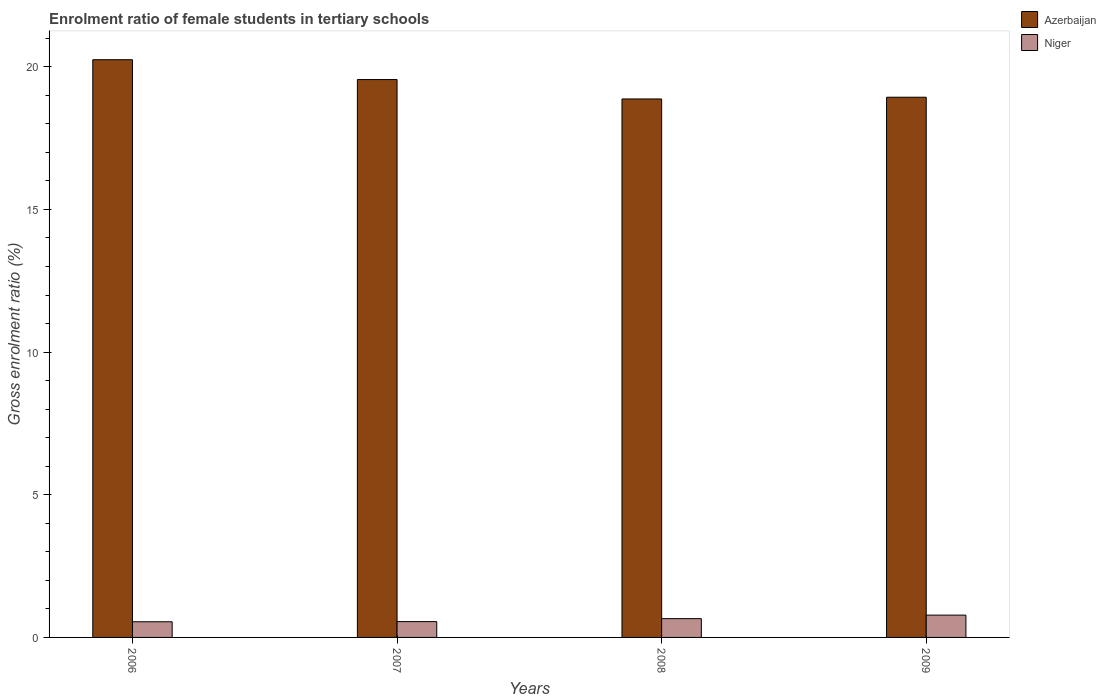What is the enrolment ratio of female students in tertiary schools in Niger in 2009?
Ensure brevity in your answer.  0.78. Across all years, what is the maximum enrolment ratio of female students in tertiary schools in Niger?
Provide a succinct answer. 0.78. Across all years, what is the minimum enrolment ratio of female students in tertiary schools in Niger?
Provide a short and direct response. 0.55. What is the total enrolment ratio of female students in tertiary schools in Azerbaijan in the graph?
Provide a short and direct response. 77.6. What is the difference between the enrolment ratio of female students in tertiary schools in Niger in 2006 and that in 2009?
Your response must be concise. -0.23. What is the difference between the enrolment ratio of female students in tertiary schools in Azerbaijan in 2008 and the enrolment ratio of female students in tertiary schools in Niger in 2006?
Your answer should be very brief. 18.32. What is the average enrolment ratio of female students in tertiary schools in Azerbaijan per year?
Give a very brief answer. 19.4. In the year 2008, what is the difference between the enrolment ratio of female students in tertiary schools in Niger and enrolment ratio of female students in tertiary schools in Azerbaijan?
Provide a succinct answer. -18.21. What is the ratio of the enrolment ratio of female students in tertiary schools in Niger in 2006 to that in 2008?
Provide a short and direct response. 0.83. Is the enrolment ratio of female students in tertiary schools in Niger in 2006 less than that in 2007?
Offer a very short reply. Yes. Is the difference between the enrolment ratio of female students in tertiary schools in Niger in 2008 and 2009 greater than the difference between the enrolment ratio of female students in tertiary schools in Azerbaijan in 2008 and 2009?
Keep it short and to the point. No. What is the difference between the highest and the second highest enrolment ratio of female students in tertiary schools in Niger?
Offer a terse response. 0.12. What is the difference between the highest and the lowest enrolment ratio of female students in tertiary schools in Azerbaijan?
Your answer should be very brief. 1.38. In how many years, is the enrolment ratio of female students in tertiary schools in Niger greater than the average enrolment ratio of female students in tertiary schools in Niger taken over all years?
Offer a terse response. 2. Is the sum of the enrolment ratio of female students in tertiary schools in Azerbaijan in 2007 and 2008 greater than the maximum enrolment ratio of female students in tertiary schools in Niger across all years?
Provide a succinct answer. Yes. What does the 2nd bar from the left in 2007 represents?
Provide a short and direct response. Niger. What does the 1st bar from the right in 2006 represents?
Your answer should be very brief. Niger. What is the difference between two consecutive major ticks on the Y-axis?
Your response must be concise. 5. Are the values on the major ticks of Y-axis written in scientific E-notation?
Ensure brevity in your answer.  No. Does the graph contain any zero values?
Give a very brief answer. No. How many legend labels are there?
Ensure brevity in your answer.  2. What is the title of the graph?
Make the answer very short. Enrolment ratio of female students in tertiary schools. Does "Least developed countries" appear as one of the legend labels in the graph?
Ensure brevity in your answer.  No. What is the label or title of the X-axis?
Keep it short and to the point. Years. What is the label or title of the Y-axis?
Your answer should be compact. Gross enrolment ratio (%). What is the Gross enrolment ratio (%) of Azerbaijan in 2006?
Provide a succinct answer. 20.25. What is the Gross enrolment ratio (%) of Niger in 2006?
Offer a terse response. 0.55. What is the Gross enrolment ratio (%) in Azerbaijan in 2007?
Provide a short and direct response. 19.55. What is the Gross enrolment ratio (%) in Niger in 2007?
Offer a terse response. 0.55. What is the Gross enrolment ratio (%) in Azerbaijan in 2008?
Provide a short and direct response. 18.87. What is the Gross enrolment ratio (%) in Niger in 2008?
Keep it short and to the point. 0.66. What is the Gross enrolment ratio (%) in Azerbaijan in 2009?
Your response must be concise. 18.93. What is the Gross enrolment ratio (%) of Niger in 2009?
Offer a terse response. 0.78. Across all years, what is the maximum Gross enrolment ratio (%) in Azerbaijan?
Make the answer very short. 20.25. Across all years, what is the maximum Gross enrolment ratio (%) of Niger?
Keep it short and to the point. 0.78. Across all years, what is the minimum Gross enrolment ratio (%) in Azerbaijan?
Keep it short and to the point. 18.87. Across all years, what is the minimum Gross enrolment ratio (%) in Niger?
Ensure brevity in your answer.  0.55. What is the total Gross enrolment ratio (%) in Azerbaijan in the graph?
Ensure brevity in your answer.  77.6. What is the total Gross enrolment ratio (%) of Niger in the graph?
Offer a very short reply. 2.54. What is the difference between the Gross enrolment ratio (%) in Azerbaijan in 2006 and that in 2007?
Your answer should be compact. 0.7. What is the difference between the Gross enrolment ratio (%) of Niger in 2006 and that in 2007?
Offer a terse response. -0.01. What is the difference between the Gross enrolment ratio (%) in Azerbaijan in 2006 and that in 2008?
Make the answer very short. 1.38. What is the difference between the Gross enrolment ratio (%) in Niger in 2006 and that in 2008?
Provide a short and direct response. -0.11. What is the difference between the Gross enrolment ratio (%) of Azerbaijan in 2006 and that in 2009?
Keep it short and to the point. 1.31. What is the difference between the Gross enrolment ratio (%) in Niger in 2006 and that in 2009?
Keep it short and to the point. -0.23. What is the difference between the Gross enrolment ratio (%) in Azerbaijan in 2007 and that in 2008?
Give a very brief answer. 0.68. What is the difference between the Gross enrolment ratio (%) in Niger in 2007 and that in 2008?
Offer a terse response. -0.1. What is the difference between the Gross enrolment ratio (%) in Azerbaijan in 2007 and that in 2009?
Offer a terse response. 0.62. What is the difference between the Gross enrolment ratio (%) in Niger in 2007 and that in 2009?
Keep it short and to the point. -0.23. What is the difference between the Gross enrolment ratio (%) of Azerbaijan in 2008 and that in 2009?
Provide a succinct answer. -0.06. What is the difference between the Gross enrolment ratio (%) in Niger in 2008 and that in 2009?
Make the answer very short. -0.12. What is the difference between the Gross enrolment ratio (%) of Azerbaijan in 2006 and the Gross enrolment ratio (%) of Niger in 2007?
Give a very brief answer. 19.69. What is the difference between the Gross enrolment ratio (%) in Azerbaijan in 2006 and the Gross enrolment ratio (%) in Niger in 2008?
Offer a terse response. 19.59. What is the difference between the Gross enrolment ratio (%) in Azerbaijan in 2006 and the Gross enrolment ratio (%) in Niger in 2009?
Give a very brief answer. 19.46. What is the difference between the Gross enrolment ratio (%) of Azerbaijan in 2007 and the Gross enrolment ratio (%) of Niger in 2008?
Provide a succinct answer. 18.89. What is the difference between the Gross enrolment ratio (%) of Azerbaijan in 2007 and the Gross enrolment ratio (%) of Niger in 2009?
Your response must be concise. 18.77. What is the difference between the Gross enrolment ratio (%) of Azerbaijan in 2008 and the Gross enrolment ratio (%) of Niger in 2009?
Offer a terse response. 18.09. What is the average Gross enrolment ratio (%) of Azerbaijan per year?
Offer a very short reply. 19.4. What is the average Gross enrolment ratio (%) of Niger per year?
Provide a succinct answer. 0.64. In the year 2006, what is the difference between the Gross enrolment ratio (%) in Azerbaijan and Gross enrolment ratio (%) in Niger?
Offer a terse response. 19.7. In the year 2007, what is the difference between the Gross enrolment ratio (%) of Azerbaijan and Gross enrolment ratio (%) of Niger?
Your response must be concise. 19. In the year 2008, what is the difference between the Gross enrolment ratio (%) in Azerbaijan and Gross enrolment ratio (%) in Niger?
Give a very brief answer. 18.21. In the year 2009, what is the difference between the Gross enrolment ratio (%) in Azerbaijan and Gross enrolment ratio (%) in Niger?
Provide a short and direct response. 18.15. What is the ratio of the Gross enrolment ratio (%) in Azerbaijan in 2006 to that in 2007?
Ensure brevity in your answer.  1.04. What is the ratio of the Gross enrolment ratio (%) of Azerbaijan in 2006 to that in 2008?
Your response must be concise. 1.07. What is the ratio of the Gross enrolment ratio (%) of Niger in 2006 to that in 2008?
Your answer should be very brief. 0.83. What is the ratio of the Gross enrolment ratio (%) in Azerbaijan in 2006 to that in 2009?
Your response must be concise. 1.07. What is the ratio of the Gross enrolment ratio (%) in Niger in 2006 to that in 2009?
Your answer should be compact. 0.7. What is the ratio of the Gross enrolment ratio (%) of Azerbaijan in 2007 to that in 2008?
Make the answer very short. 1.04. What is the ratio of the Gross enrolment ratio (%) of Niger in 2007 to that in 2008?
Your answer should be very brief. 0.84. What is the ratio of the Gross enrolment ratio (%) in Azerbaijan in 2007 to that in 2009?
Offer a terse response. 1.03. What is the ratio of the Gross enrolment ratio (%) of Niger in 2007 to that in 2009?
Your answer should be compact. 0.71. What is the ratio of the Gross enrolment ratio (%) in Azerbaijan in 2008 to that in 2009?
Make the answer very short. 1. What is the ratio of the Gross enrolment ratio (%) in Niger in 2008 to that in 2009?
Offer a terse response. 0.84. What is the difference between the highest and the second highest Gross enrolment ratio (%) of Azerbaijan?
Your response must be concise. 0.7. What is the difference between the highest and the second highest Gross enrolment ratio (%) in Niger?
Provide a short and direct response. 0.12. What is the difference between the highest and the lowest Gross enrolment ratio (%) in Azerbaijan?
Your response must be concise. 1.38. What is the difference between the highest and the lowest Gross enrolment ratio (%) in Niger?
Your response must be concise. 0.23. 